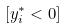Convert formula to latex. <formula><loc_0><loc_0><loc_500><loc_500>[ y _ { i } ^ { * } < 0 ]</formula> 